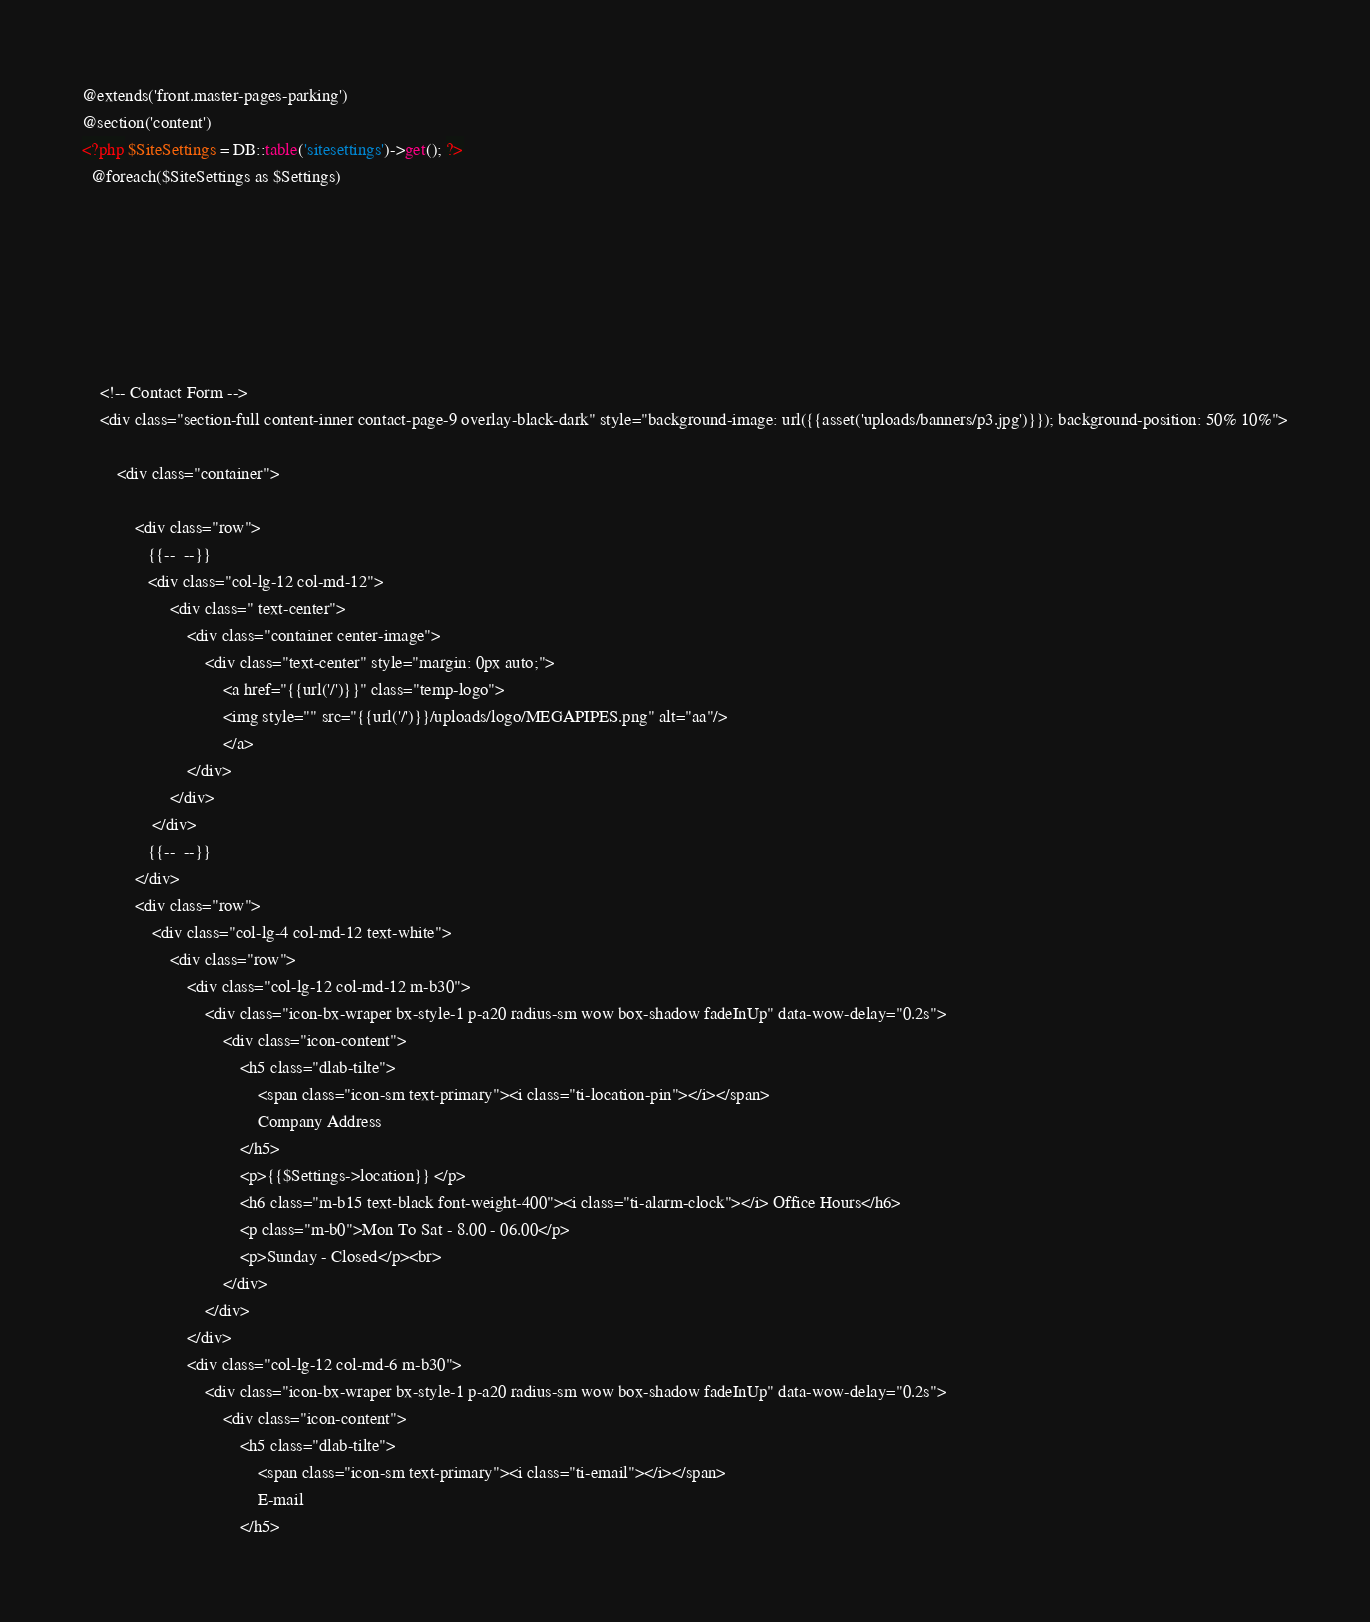<code> <loc_0><loc_0><loc_500><loc_500><_PHP_>@extends('front.master-pages-parking')
@section('content')
<?php $SiteSettings = DB::table('sitesettings')->get(); ?>
  @foreach($SiteSettings as $Settings)
  
 

       
 


    <!-- Contact Form -->
    <div class="section-full content-inner contact-page-9 overlay-black-dark" style="background-image: url({{asset('uploads/banners/p3.jpg')}}); background-position: 50% 10%">
  
        <div class="container">
            
            <div class="row">
               {{--  --}}
               <div class="col-lg-12 col-md-12">
                    <div class=" text-center">
                        <div class="container center-image">
                            <div class="text-center" style="margin: 0px auto;">
                                <a href="{{url('/')}}" class="temp-logo">
                                <img style="" src="{{url('/')}}/uploads/logo/MEGAPIPES.png" alt="aa"/>
                                </a>
                        </div>	
                    </div>
                </div>
               {{--  --}}
            </div>
            <div class="row">
                <div class="col-lg-4 col-md-12 text-white">
                    <div class="row">
                        <div class="col-lg-12 col-md-12 m-b30">
                            <div class="icon-bx-wraper bx-style-1 p-a20 radius-sm wow box-shadow fadeInUp" data-wow-delay="0.2s">
                                <div class="icon-content">
                                    <h5 class="dlab-tilte">
                                        <span class="icon-sm text-primary"><i class="ti-location-pin"></i></span> 
                                        Company Address
                                    </h5>
                                    <p>{{$Settings->location}} </p>
                                    <h6 class="m-b15 text-black font-weight-400"><i class="ti-alarm-clock"></i> Office Hours</h6>
                                    <p class="m-b0">Mon To Sat - 8.00 - 06.00</p>
                                    <p>Sunday - Closed</p><br>
                                </div>
                            </div>
                        </div>
                        <div class="col-lg-12 col-md-6 m-b30">
                            <div class="icon-bx-wraper bx-style-1 p-a20 radius-sm wow box-shadow fadeInUp" data-wow-delay="0.2s">
                                <div class="icon-content">
                                    <h5 class="dlab-tilte">
                                        <span class="icon-sm text-primary"><i class="ti-email"></i></span> 
                                        E-mail
                                    </h5></code> 